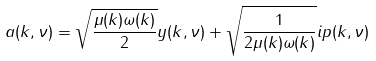<formula> <loc_0><loc_0><loc_500><loc_500>a ( k , \nu ) = \sqrt { \frac { \mu ( k ) \omega ( k ) } { 2 } } y ( k , \nu ) + \sqrt { \frac { 1 } { 2 \mu ( k ) \omega ( k ) } } i p ( k , \nu )</formula> 